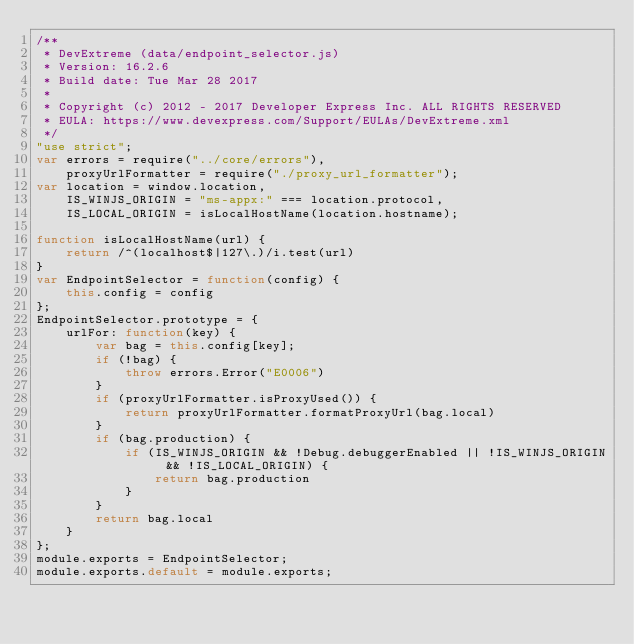<code> <loc_0><loc_0><loc_500><loc_500><_JavaScript_>/**
 * DevExtreme (data/endpoint_selector.js)
 * Version: 16.2.6
 * Build date: Tue Mar 28 2017
 *
 * Copyright (c) 2012 - 2017 Developer Express Inc. ALL RIGHTS RESERVED
 * EULA: https://www.devexpress.com/Support/EULAs/DevExtreme.xml
 */
"use strict";
var errors = require("../core/errors"),
    proxyUrlFormatter = require("./proxy_url_formatter");
var location = window.location,
    IS_WINJS_ORIGIN = "ms-appx:" === location.protocol,
    IS_LOCAL_ORIGIN = isLocalHostName(location.hostname);

function isLocalHostName(url) {
    return /^(localhost$|127\.)/i.test(url)
}
var EndpointSelector = function(config) {
    this.config = config
};
EndpointSelector.prototype = {
    urlFor: function(key) {
        var bag = this.config[key];
        if (!bag) {
            throw errors.Error("E0006")
        }
        if (proxyUrlFormatter.isProxyUsed()) {
            return proxyUrlFormatter.formatProxyUrl(bag.local)
        }
        if (bag.production) {
            if (IS_WINJS_ORIGIN && !Debug.debuggerEnabled || !IS_WINJS_ORIGIN && !IS_LOCAL_ORIGIN) {
                return bag.production
            }
        }
        return bag.local
    }
};
module.exports = EndpointSelector;
module.exports.default = module.exports;
</code> 